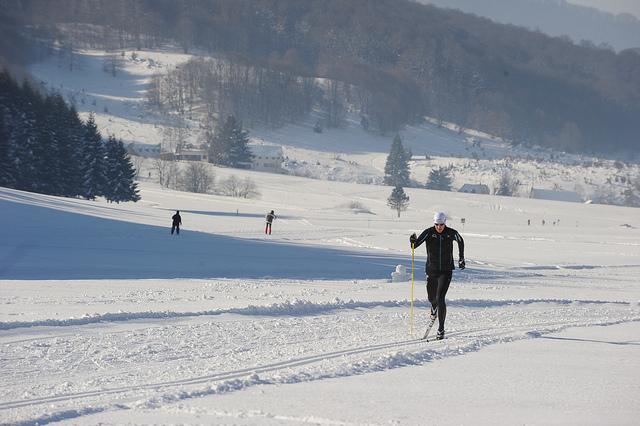What sport is the person engaging in?
Quick response, please. Skiing. Is it cold?
Give a very brief answer. Yes. Where are the people?
Give a very brief answer. Snow. Is this a team sport?
Give a very brief answer. No. What sport is the person playing?
Quick response, please. Skiing. 